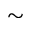<formula> <loc_0><loc_0><loc_500><loc_500>\sim</formula> 